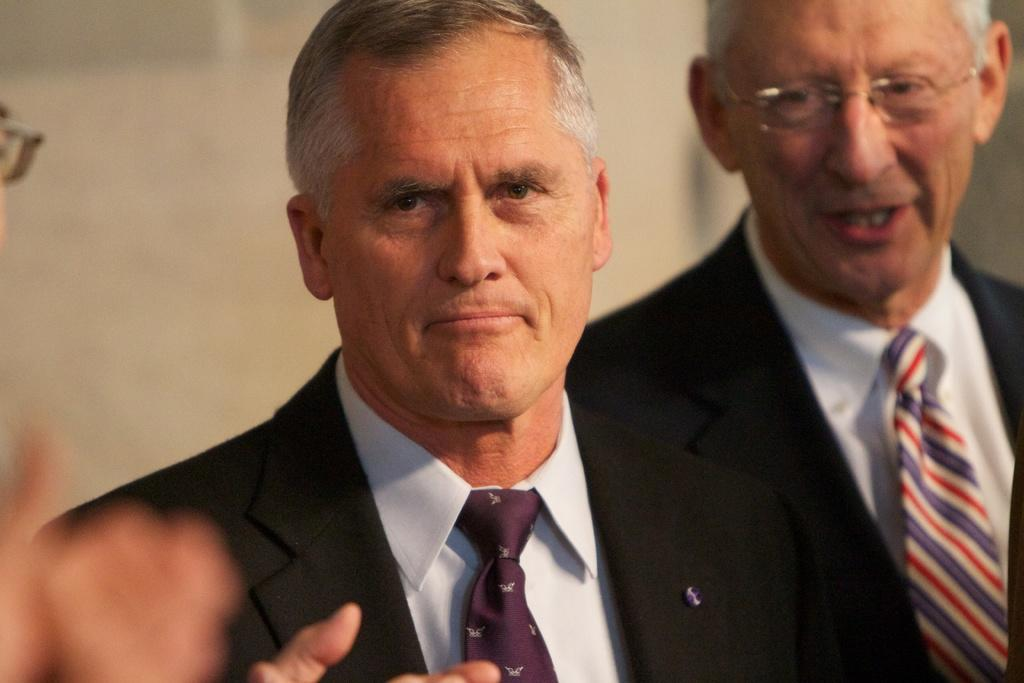Who is the main subject in the image? There is a man in the center of the image. Are there any other people present in the image? Yes, there are other people on both sides of the man. What type of beetle can be seen crawling on the man's shoulder in the image? There is no beetle present on the man's shoulder in the image. How many boats are visible in the image? There are no boats visible in the image. 